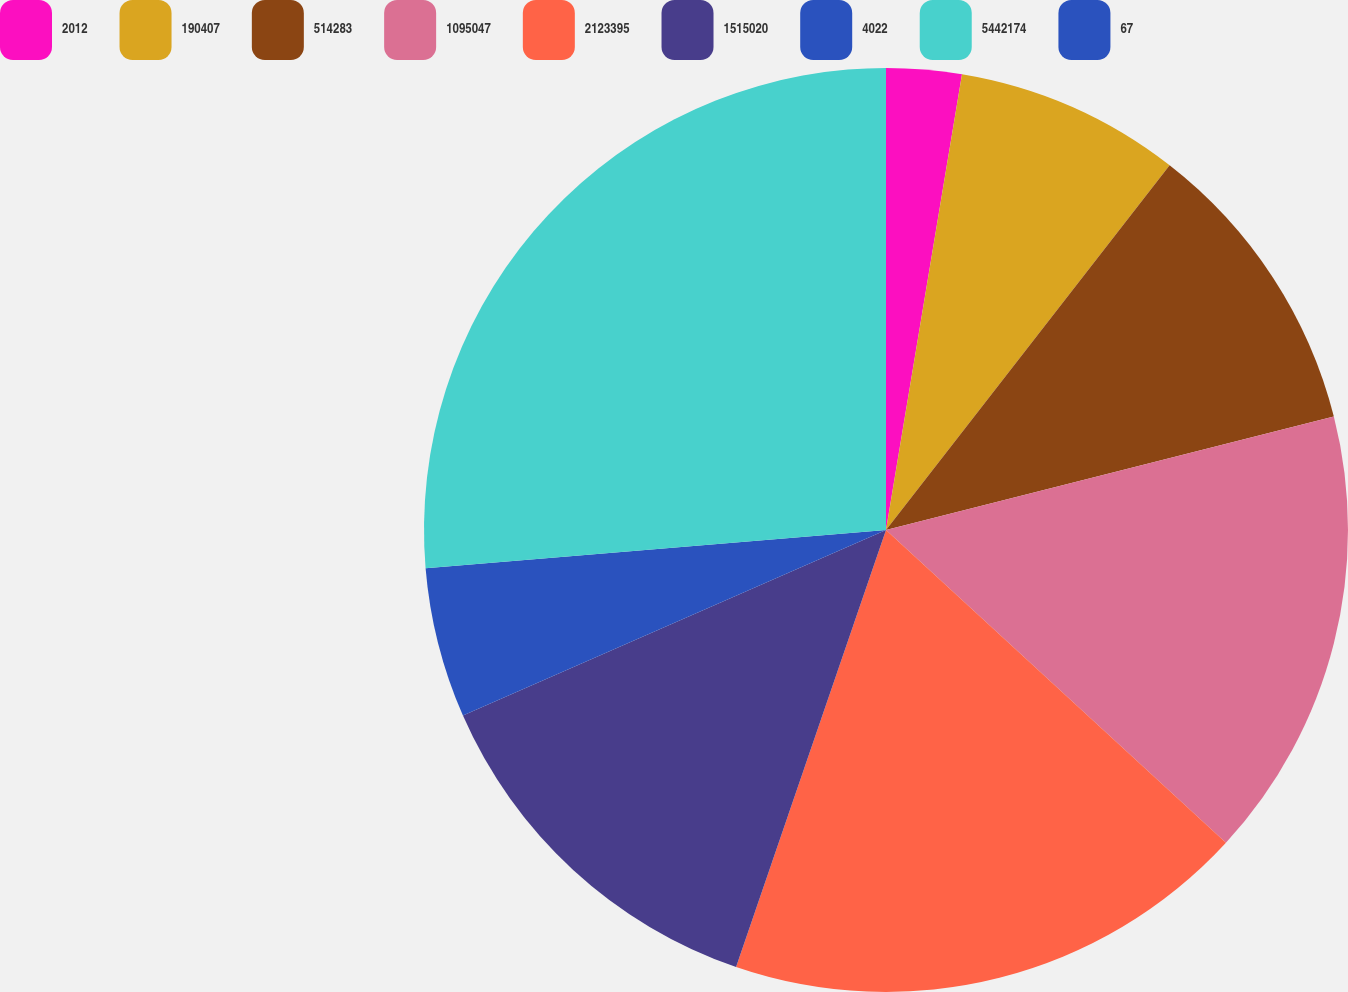Convert chart to OTSL. <chart><loc_0><loc_0><loc_500><loc_500><pie_chart><fcel>2012<fcel>190407<fcel>514283<fcel>1095047<fcel>2123395<fcel>1515020<fcel>4022<fcel>5442174<fcel>67<nl><fcel>2.63%<fcel>7.89%<fcel>10.53%<fcel>15.79%<fcel>18.42%<fcel>13.16%<fcel>5.26%<fcel>26.32%<fcel>0.0%<nl></chart> 